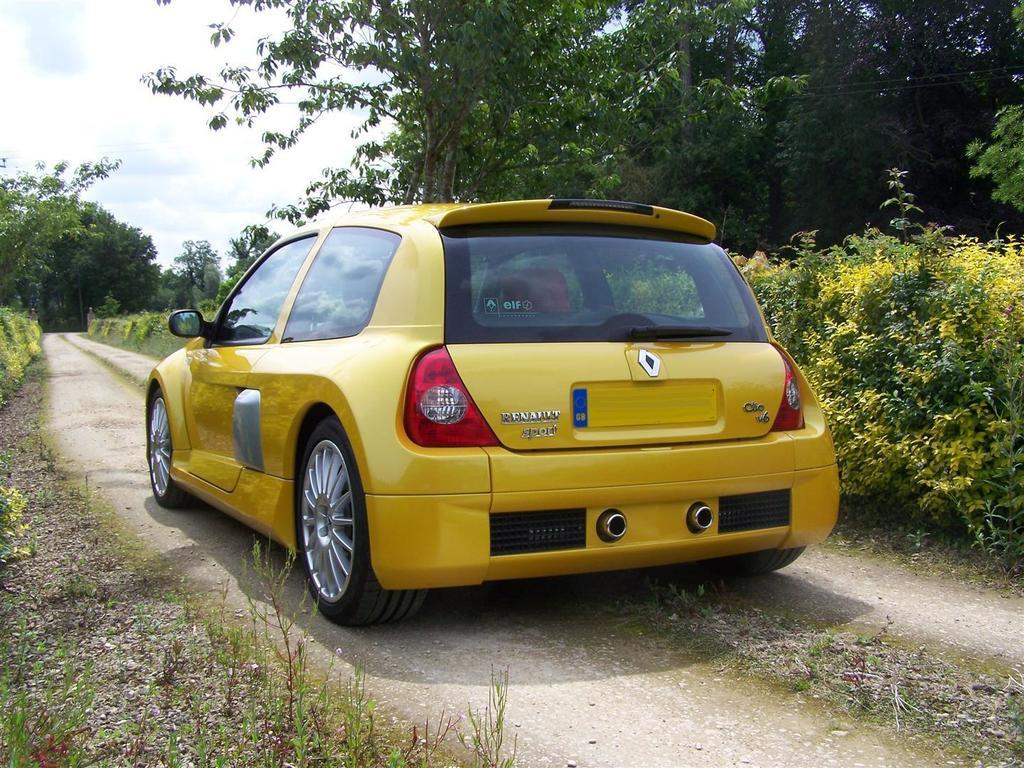What color is the car in the image? The car in the image is yellow. Where is the car located in the image? The car is in the middle of a path in the image. What can be seen on either side of the car? Plants and trees are present on either side of the car in the image. What is visible in the background of the image? The sky is visible in the image, and clouds are present in the sky. What direction is the car heading in the image? The image does not provide information about the direction the car is heading; it only shows the car in the middle of a path. 